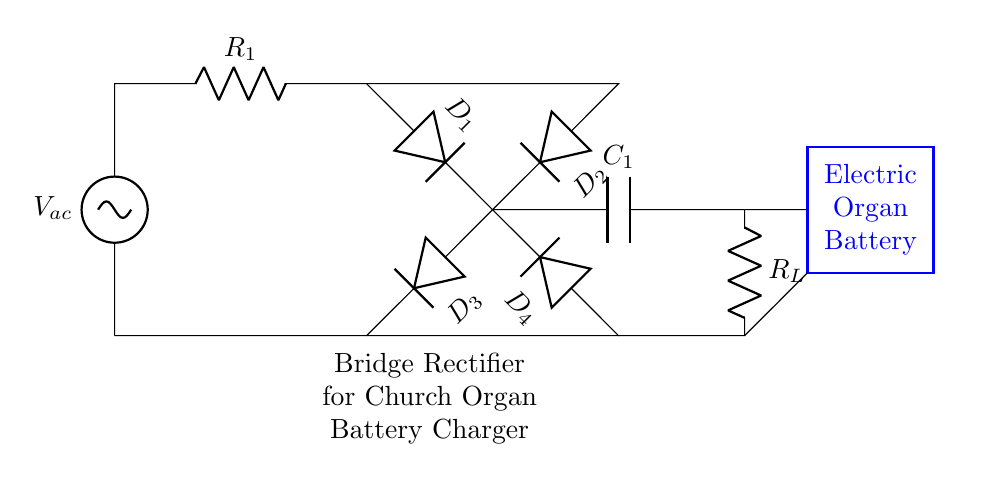What type of circuit is shown? The circuit is a bridge rectifier circuit, which is specifically designed to convert alternating current to direct current. It uses four diodes arranged in a bridge configuration.
Answer: bridge rectifier How many diodes are used in this circuit? The circuit contains four diodes, labeled as D1, D2, D3, and D4. Each diode plays a crucial role in converting AC to DC.
Answer: four What is the role of the capacitor in this circuit? The capacitor, labeled C1, is used for smoothing the output voltage, reducing ripple by storing and releasing charge to provide a steadier DC output.
Answer: smoothing What does R_L represent in the circuit? R_L represents the load resistor, which in this case is the electric organ that utilizes the power generated by the rectifier circuit.
Answer: load resistor Which components create the AC input in the circuit? The AC input is provided by the voltage source labeled as V_ac in the circuit diagram, which supplies alternating current to the rectifier.
Answer: V_ac What is the output of this circuit? The output of this bridge rectifier circuit is a direct current that charges the battery of the electric organ, indicated by the connection to the electric organ battery.
Answer: direct current Explain how the diodes are connected in this bridge rectifier circuit. The four diodes are arranged in a bridge configuration where D1 and D2 connect to one AC input, while D3 and D4 connect to the other. This arrangement allows current to flow during both halves of the AC cycle, effectively rectifying the AC input to DC.
Answer: bridge configuration 